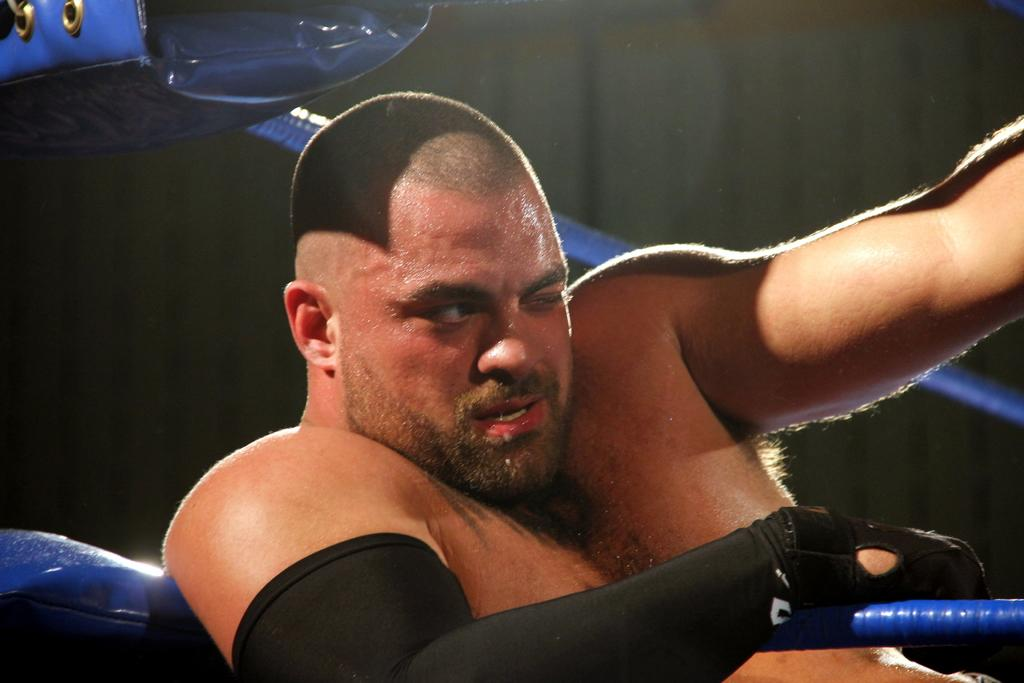Who is present in the image? There is a man in the image. What can be seen in the image besides the man? There are blue color ropes in the image. What type of pump is being used to inflate the cushion in the image? There is no pump or cushion present in the image; it only features a man and blue color ropes. 